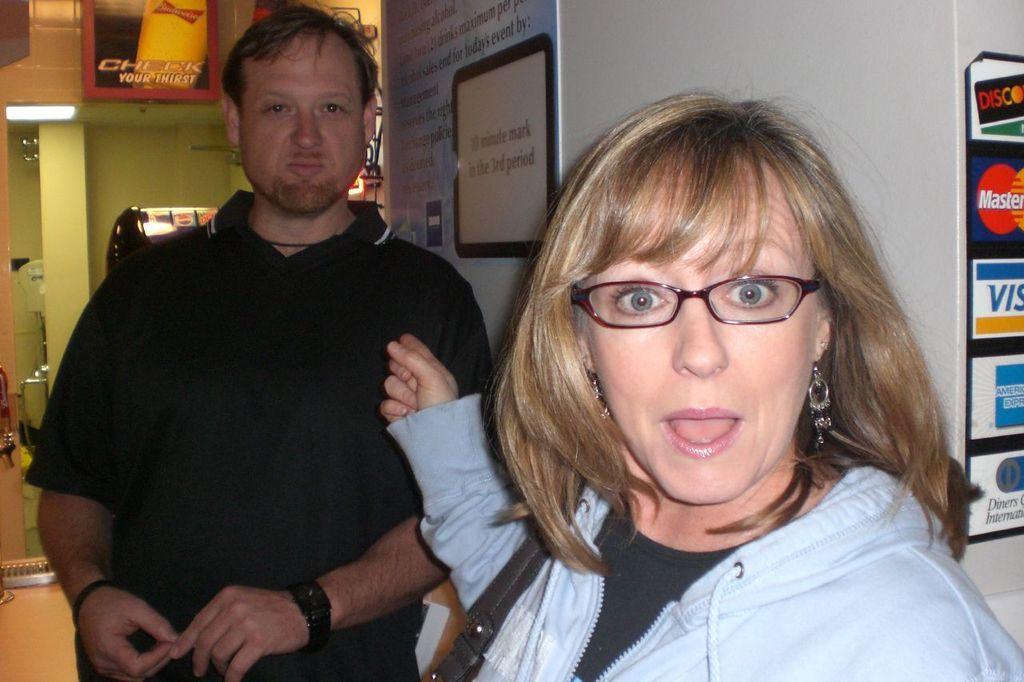How would you summarize this image in a sentence or two? Here I can see a man and a woman are looking at the picture. The woman is wearing a jacket and it seems like she is speaking. The man is wearing a black color t-shirt. At the back of these people I can see a wall to which a board and a poster are attached. In the background there is a pillar and few objects are placed on the floor. 